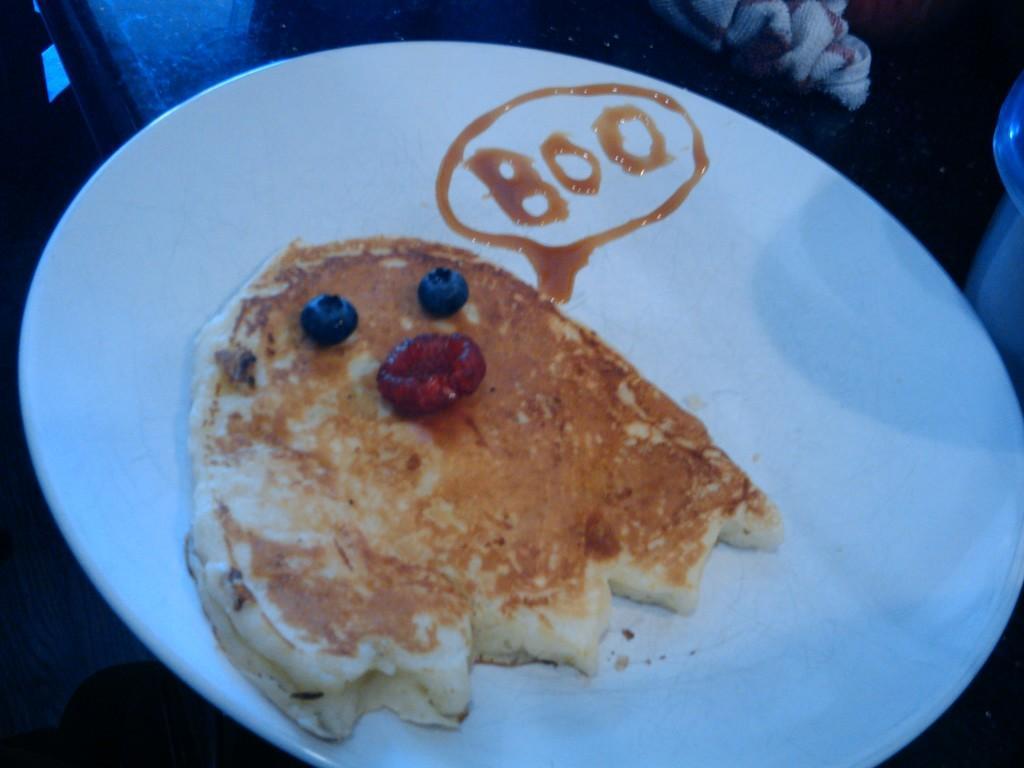In one or two sentences, can you explain what this image depicts? In this there is a plate and we can see a pancake and cherries placed on the plate. At the bottom there is a table. 